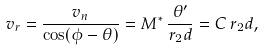<formula> <loc_0><loc_0><loc_500><loc_500>v _ { r } = \frac { v _ { n } } { \cos ( \phi - \theta ) } = M ^ { * } \, \frac { \theta ^ { \prime } } { r _ { 2 } d } = C \, r _ { 2 } d ,</formula> 